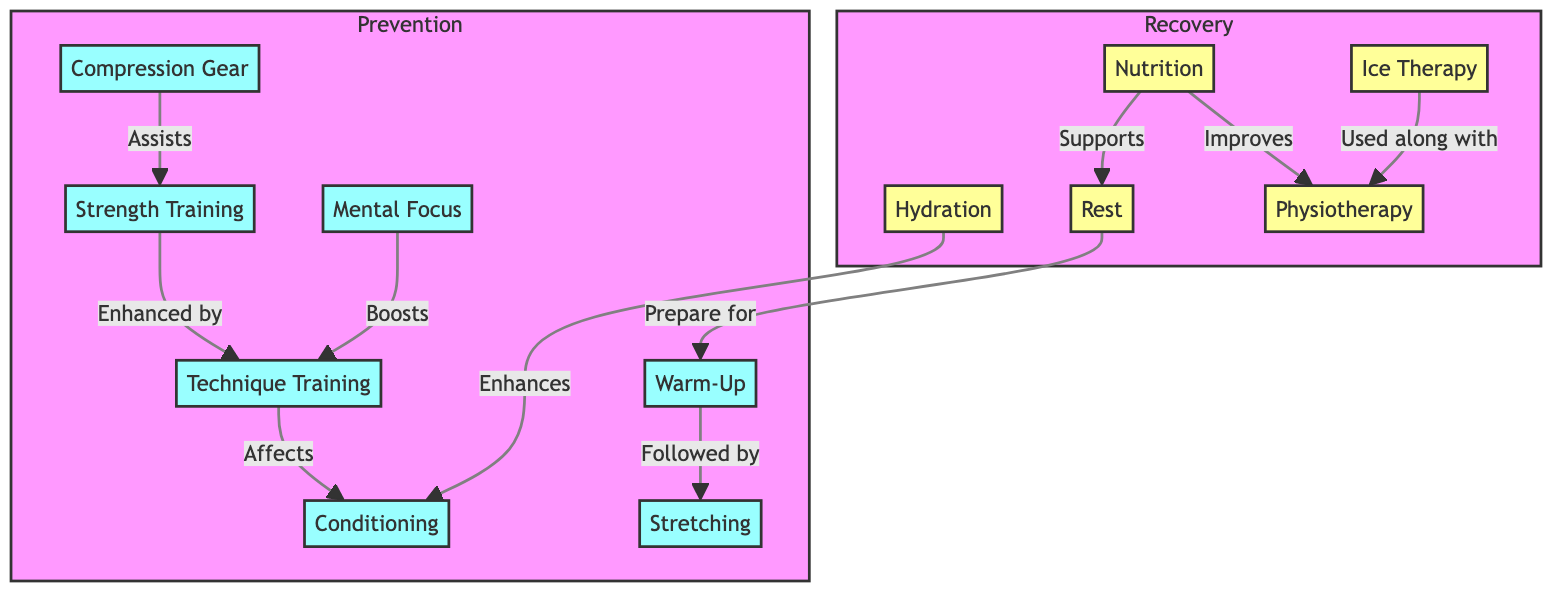What are the two main categories in the diagram? The diagram is divided into two main categories: Prevention and Recovery. These categories are indicated by different color schemes and contain related nodes.
Answer: Prevention and Recovery How many nodes are present in the Prevention category? In the Prevention category, there are seven nodes listed: Warm-Up, Stretching, Strength Training, Conditioning, Technique Training, Compression Gear, and Mental Focus. By counting these, we find there are 7 nodes.
Answer: 7 What supports Rest in the Recovery category? In the diagram, Nutrition is shown as supporting Rest. This relationship is explicitly indicated connecting Nutrition to Rest.
Answer: Nutrition Which technique is used along with Ice Therapy? Ice Therapy is noted to be used along with Physiotherapy; this connection is shown in the diagram, indicating a direct relationship between these two techniques.
Answer: Physiotherapy How does Hydration affect Conditioning? According to the diagram, Hydration enhances Conditioning. This implies that proper hydration positively influences physical conditioning in wrestlers, as represented by the link.
Answer: Enhances What role does Mental Focus play in the Prevention category? Mental Focus boosts Technique Training, indicating that a wrestler's concentration and mindset can improve their technical skill execution during training, as detailed in the diagram.
Answer: Boosts How are Strength Training and Technique Training related in the diagram? Strength Training is shown to be enhanced by Technique Training; this relationship indicates that improving technique can lead to better strength training outcomes.
Answer: Enhanced What is the relationship between Warm-Up and Stretching? The diagram indicates that Warm-Up is followed by Stretching, showing a sequential relationship and suggesting that a proper warm-up is essential before stretching exercises.
Answer: Followed by Which elements in Recovery support Physiotherapy? In the Recovery category, both Nutrition and Rest improve Physiotherapy. The relationships depict how adequate nutrition and rest can aid in recovery processes involving physiotherapy.
Answer: Nutrition and Rest 